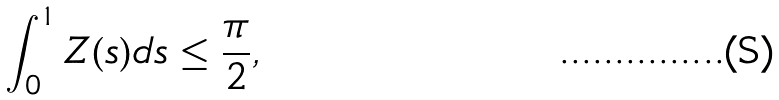Convert formula to latex. <formula><loc_0><loc_0><loc_500><loc_500>\int _ { 0 } ^ { 1 } Z ( s ) d s \leq \frac { \pi } { 2 } ,</formula> 